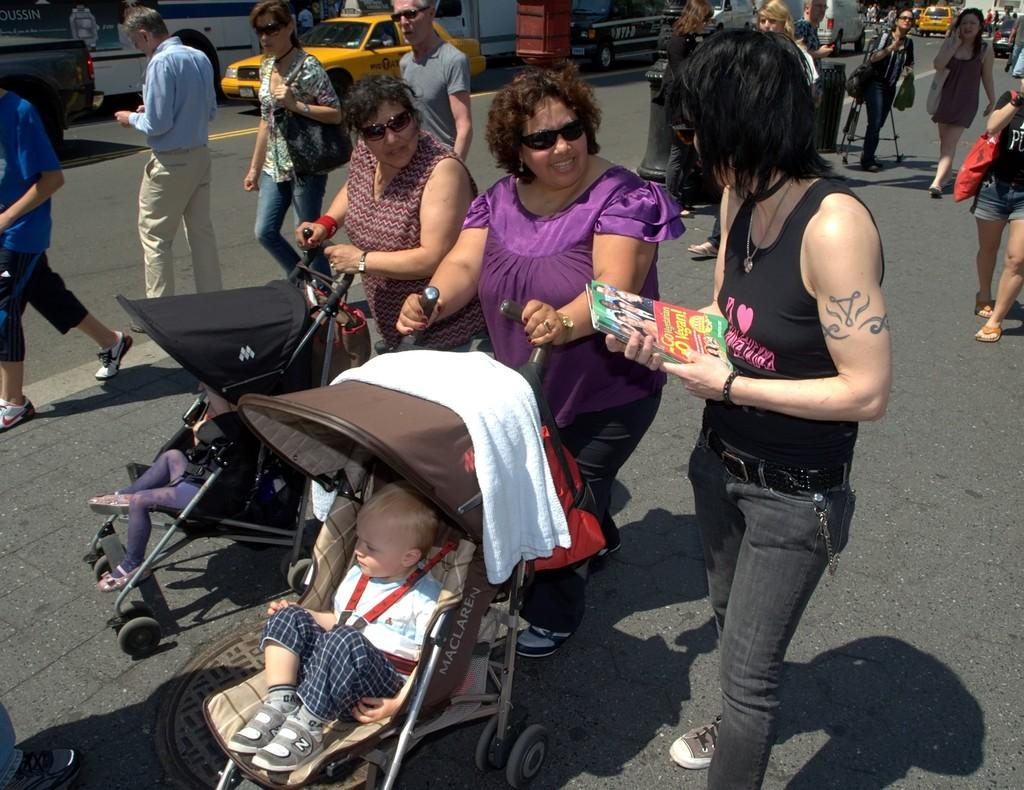Who can be seen in the image? There are people in the image. What are the children doing in the image? The children are in a baby stroller. What can be seen on the road in the image? There are vehicles visible on the road. What type of zipper can be seen on the baby stroller in the image? There is no zipper present on the baby stroller in the image. How many bites of food can be seen in the image? There is no food or bites visible in the image. 